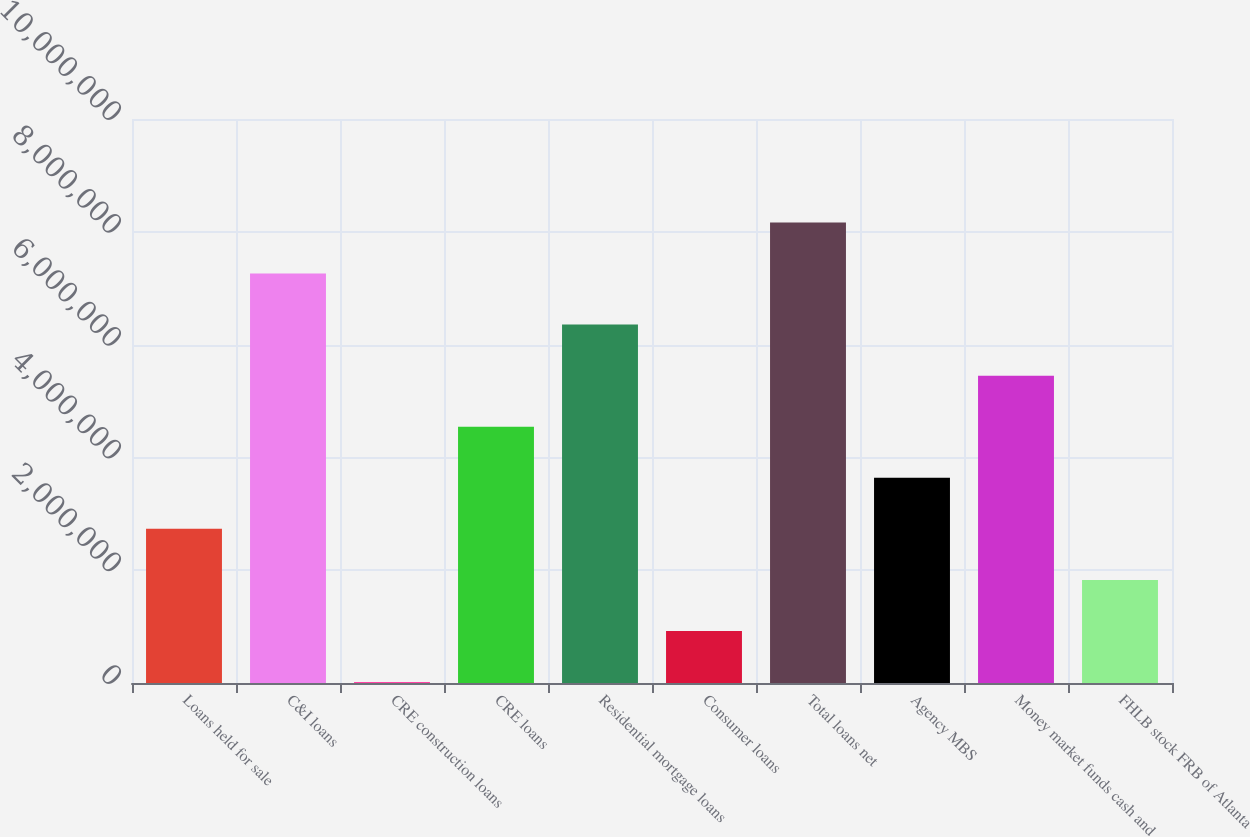Convert chart to OTSL. <chart><loc_0><loc_0><loc_500><loc_500><bar_chart><fcel>Loans held for sale<fcel>C&I loans<fcel>CRE construction loans<fcel>CRE loans<fcel>Residential mortgage loans<fcel>Consumer loans<fcel>Total loans net<fcel>Agency MBS<fcel>Money market funds cash and<fcel>FHLB stock FRB of Atlanta<nl><fcel>2.73311e+06<fcel>7.26111e+06<fcel>16314<fcel>4.54431e+06<fcel>6.35551e+06<fcel>921914<fcel>8.16671e+06<fcel>3.63871e+06<fcel>5.44991e+06<fcel>1.82751e+06<nl></chart> 